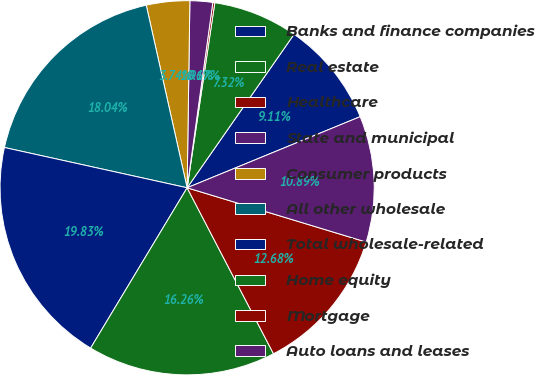Convert chart to OTSL. <chart><loc_0><loc_0><loc_500><loc_500><pie_chart><fcel>Banks and finance companies<fcel>Real estate<fcel>Healthcare<fcel>State and municipal<fcel>Consumer products<fcel>All other wholesale<fcel>Total wholesale-related<fcel>Home equity<fcel>Mortgage<fcel>Auto loans and leases<nl><fcel>9.11%<fcel>7.32%<fcel>0.17%<fcel>1.96%<fcel>3.74%<fcel>18.04%<fcel>19.83%<fcel>16.26%<fcel>12.68%<fcel>10.89%<nl></chart> 